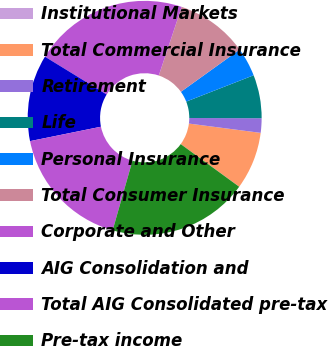<chart> <loc_0><loc_0><loc_500><loc_500><pie_chart><fcel>Institutional Markets<fcel>Total Commercial Insurance<fcel>Retirement<fcel>Life<fcel>Personal Insurance<fcel>Total Consumer Insurance<fcel>Corporate and Other<fcel>AIG Consolidation and<fcel>Total AIG Consolidated pre-tax<fcel>Pre-tax income<nl><fcel>0.01%<fcel>7.97%<fcel>2.0%<fcel>5.98%<fcel>3.99%<fcel>9.96%<fcel>21.38%<fcel>11.95%<fcel>17.4%<fcel>19.39%<nl></chart> 